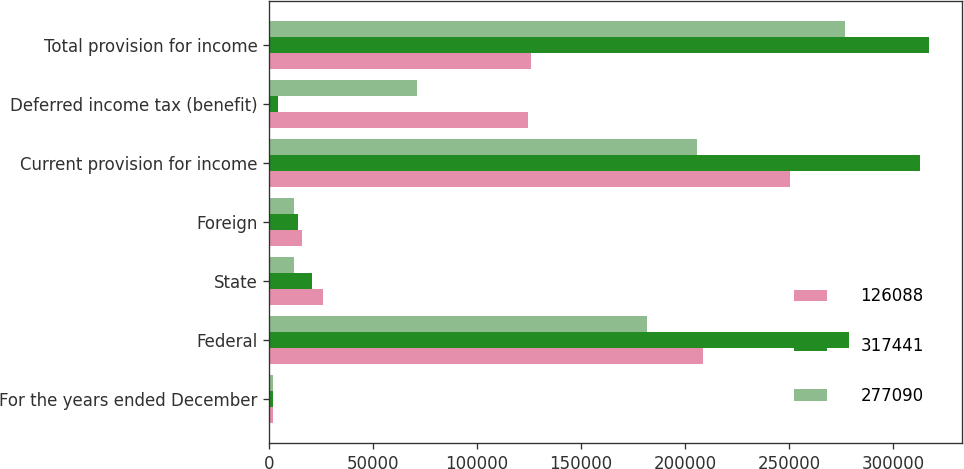<chart> <loc_0><loc_0><loc_500><loc_500><stacked_bar_chart><ecel><fcel>For the years ended December<fcel>Federal<fcel>State<fcel>Foreign<fcel>Current provision for income<fcel>Deferred income tax (benefit)<fcel>Total provision for income<nl><fcel>126088<fcel>2007<fcel>208754<fcel>26082<fcel>15528<fcel>250364<fcel>124276<fcel>126088<nl><fcel>317441<fcel>2006<fcel>279017<fcel>20569<fcel>13682<fcel>313268<fcel>4173<fcel>317441<nl><fcel>277090<fcel>2005<fcel>181947<fcel>12029<fcel>12076<fcel>206052<fcel>71038<fcel>277090<nl></chart> 